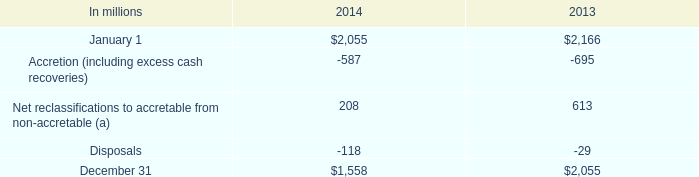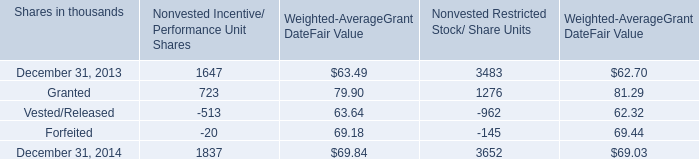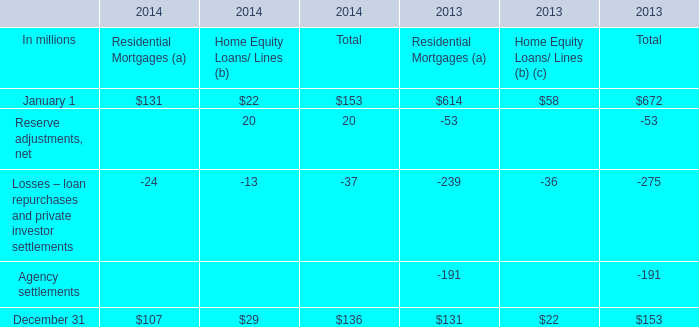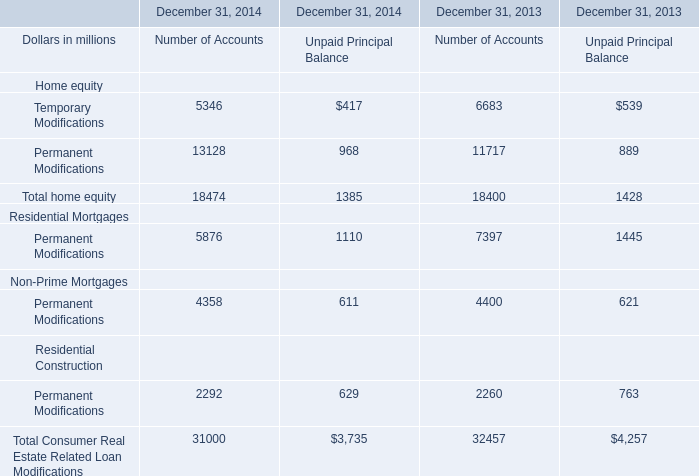what's the total amount of December 31, 2013 of Nonvested Incentive/ Performance Unit Shares, and December 31 of 2014 ? 
Computations: (1647.0 + 1558.0)
Answer: 3205.0. 